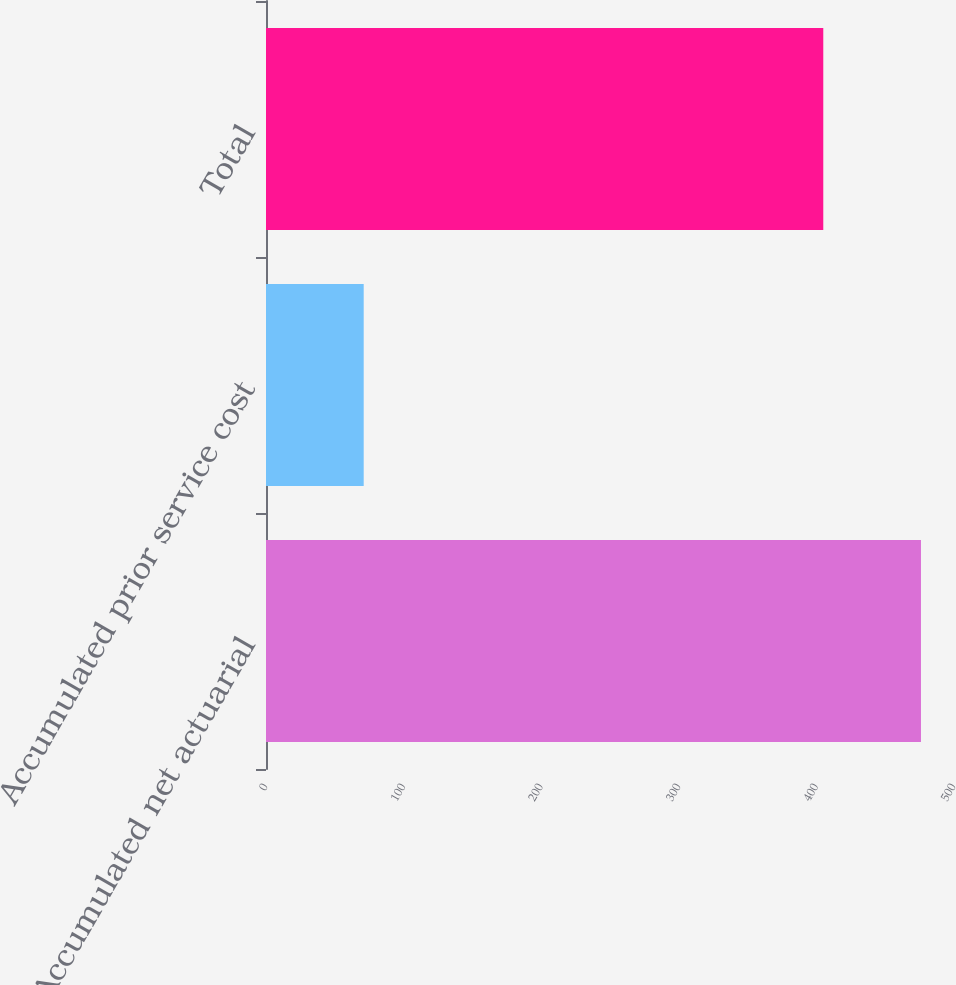Convert chart to OTSL. <chart><loc_0><loc_0><loc_500><loc_500><bar_chart><fcel>Accumulated net actuarial<fcel>Accumulated prior service cost<fcel>Total<nl><fcel>476<fcel>71<fcel>405<nl></chart> 